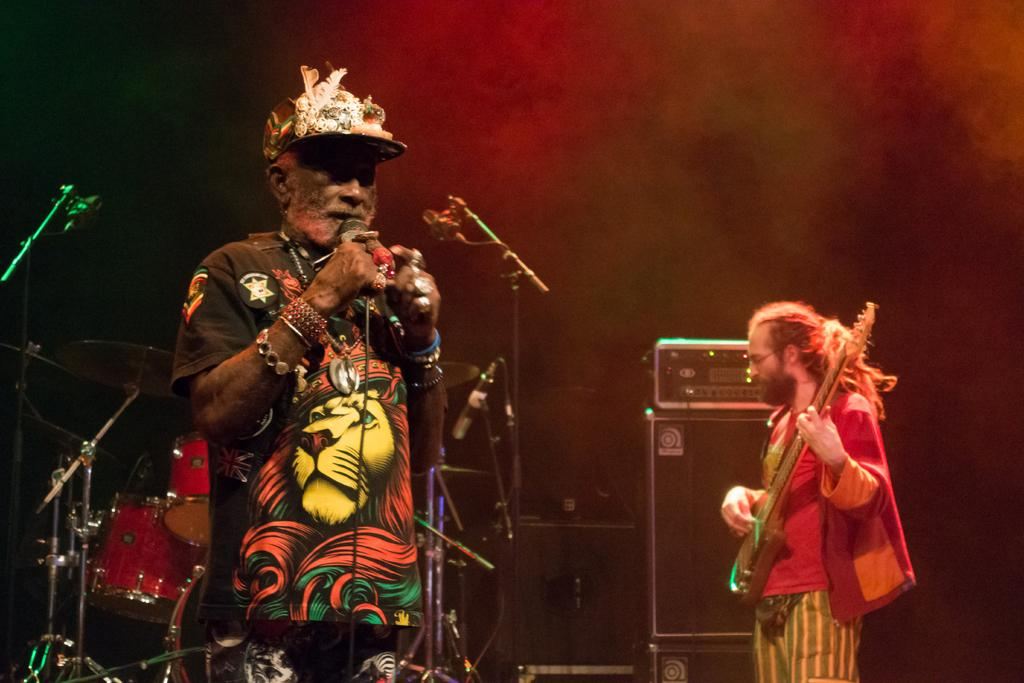What is the person on the left side of the image holding? The person on the left side of the image is holding a microphone. What is the person on the right side of the image holding? The person on the right side of the image is holding a guitar. What musical instrument can be seen in the background of the image? There are drums visible in the image. How many microphones are visible in the image? There are additional microphones with stands in the image. What type of card is being used to rub the house in the image? There is no card or house present in the image; it features two people with musical instruments and additional equipment. 